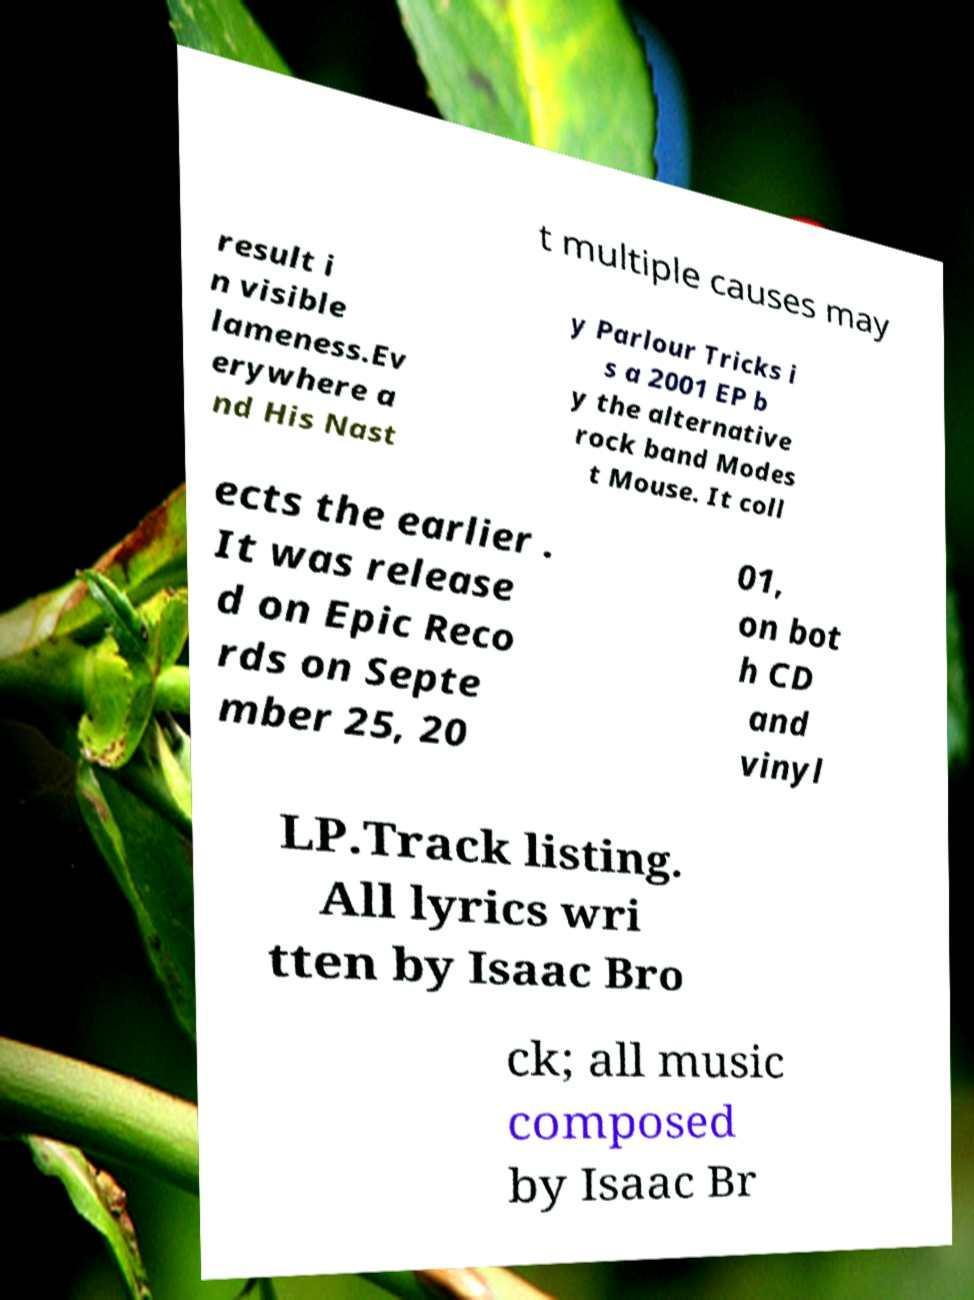I need the written content from this picture converted into text. Can you do that? t multiple causes may result i n visible lameness.Ev erywhere a nd His Nast y Parlour Tricks i s a 2001 EP b y the alternative rock band Modes t Mouse. It coll ects the earlier . It was release d on Epic Reco rds on Septe mber 25, 20 01, on bot h CD and vinyl LP.Track listing. All lyrics wri tten by Isaac Bro ck; all music composed by Isaac Br 